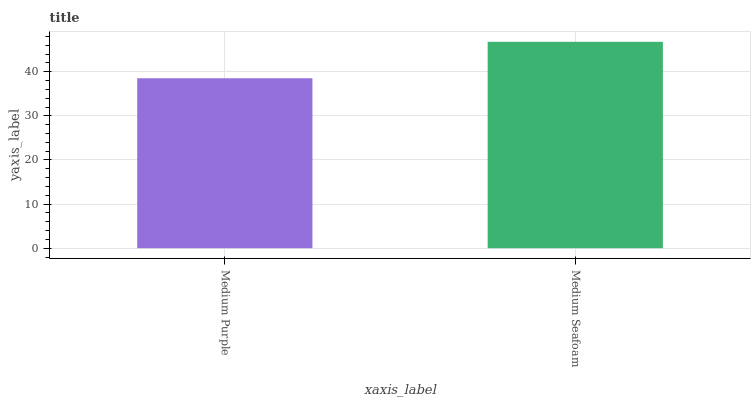Is Medium Seafoam the minimum?
Answer yes or no. No. Is Medium Seafoam greater than Medium Purple?
Answer yes or no. Yes. Is Medium Purple less than Medium Seafoam?
Answer yes or no. Yes. Is Medium Purple greater than Medium Seafoam?
Answer yes or no. No. Is Medium Seafoam less than Medium Purple?
Answer yes or no. No. Is Medium Seafoam the high median?
Answer yes or no. Yes. Is Medium Purple the low median?
Answer yes or no. Yes. Is Medium Purple the high median?
Answer yes or no. No. Is Medium Seafoam the low median?
Answer yes or no. No. 